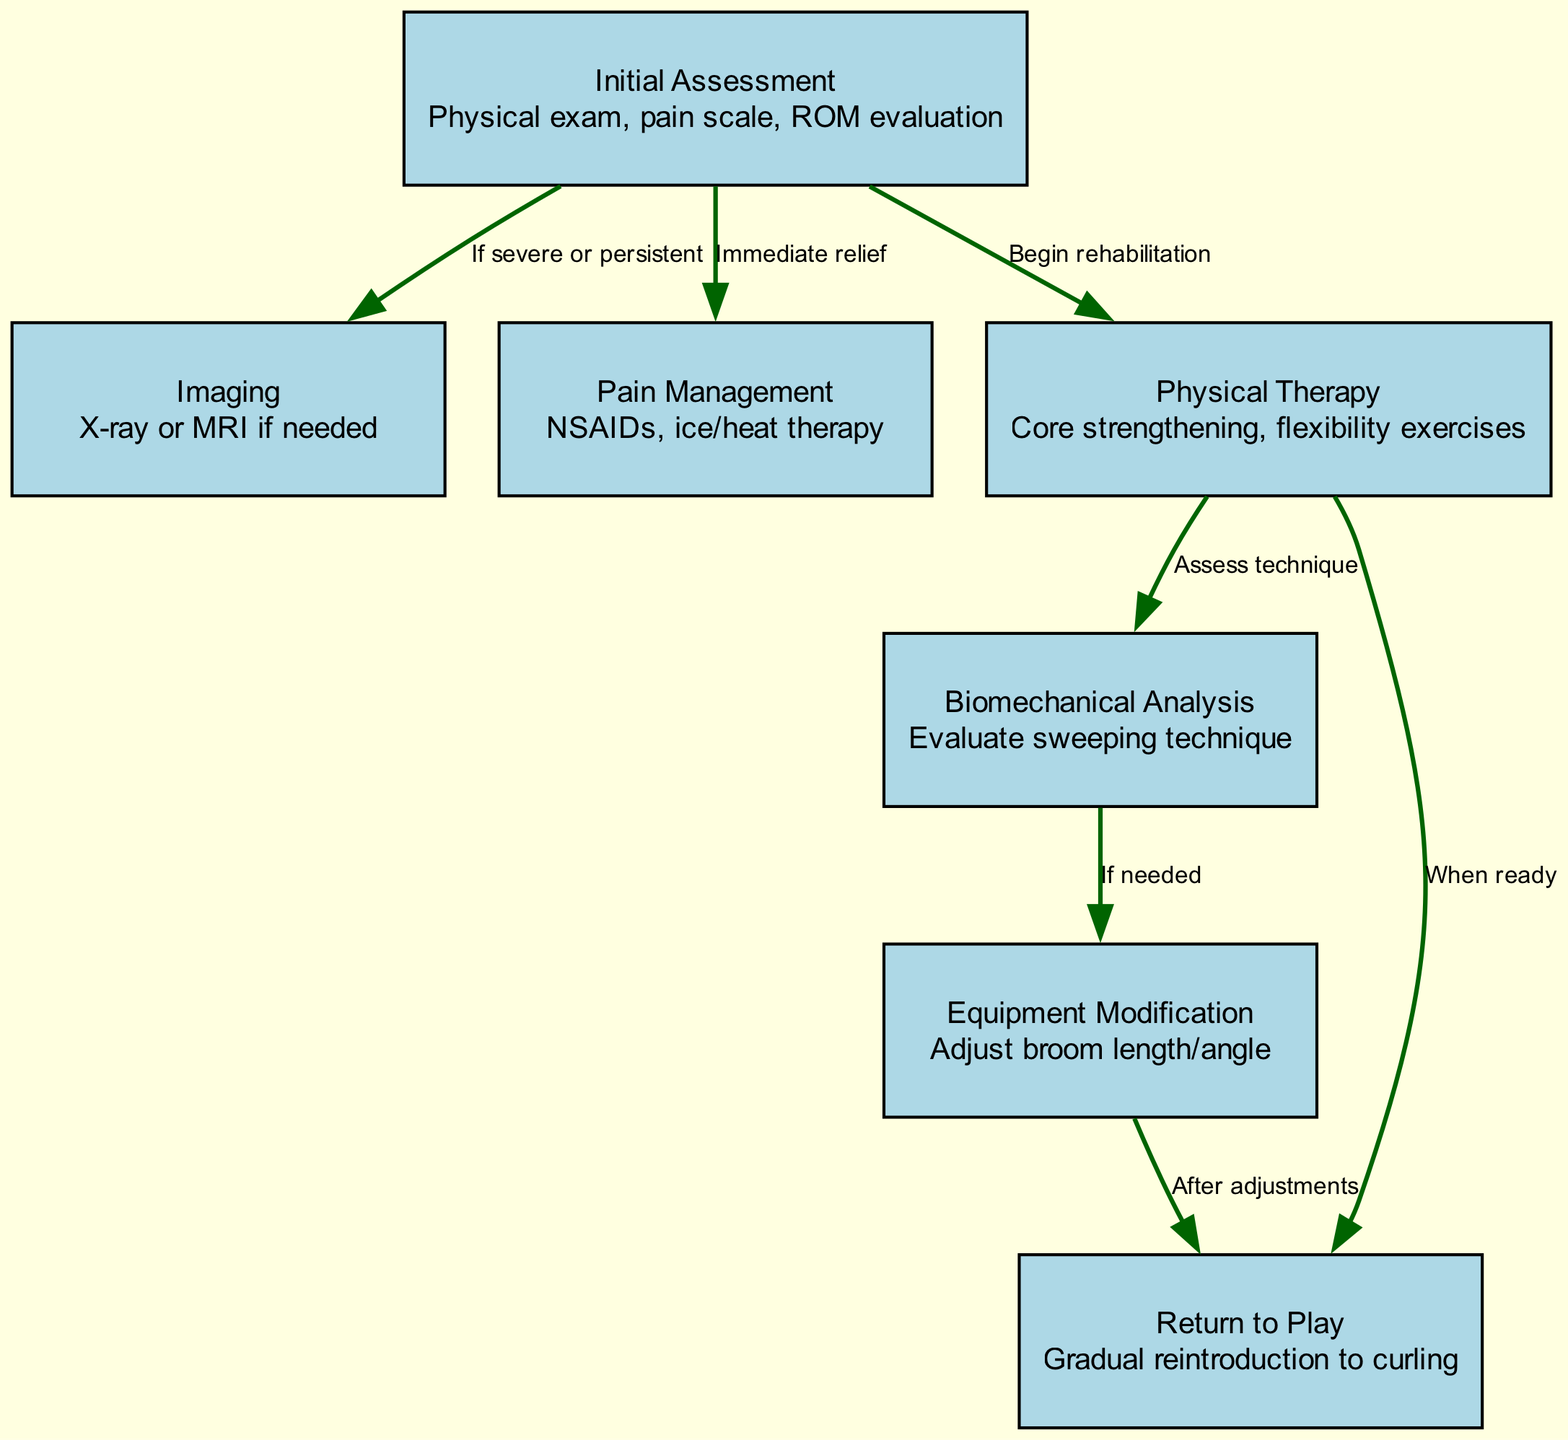What is the first step in the rehabilitation pathway? The first step is "Initial Assessment," which includes a physical exam, pain scale, and range of motion evaluation.
Answer: Initial Assessment How many nodes are present in the diagram? The diagram contains a total of 7 nodes, which represent various stages in the rehabilitation pathway.
Answer: 7 What is the relationship between "Physical Therapy" and "Biomechanical Analysis"? "Physical Therapy" leads to "Biomechanical Analysis," as indicated by an edge labeled "Assess technique."
Answer: Assess technique What is recommended if the initial assessment indicates severe or persistent pain? If the initial assessment indicates severe or persistent pain, "Imaging" is recommended, such as X-ray or MRI.
Answer: Imaging Which step follows "Physical Therapy" if the technique assessment shows it is needed? If the technique assessment shows it is needed, the next step is "Equipment Modification" to adjust broom length or angle.
Answer: Equipment Modification After "Equipment Modification," what is the next step? The next step after "Equipment Modification" is "Return to Play," which occurs after adjustments have been made.
Answer: Return to Play What treatment is provided immediately after the initial assessment? The immediate treatment provided after the initial assessment is "Pain Management," including NSAIDs and ice/heat therapy.
Answer: Pain Management When can a curler return to play according to the pathway? A curler can return to play when they are ready, following the appropriate rehabilitation steps.
Answer: When ready 